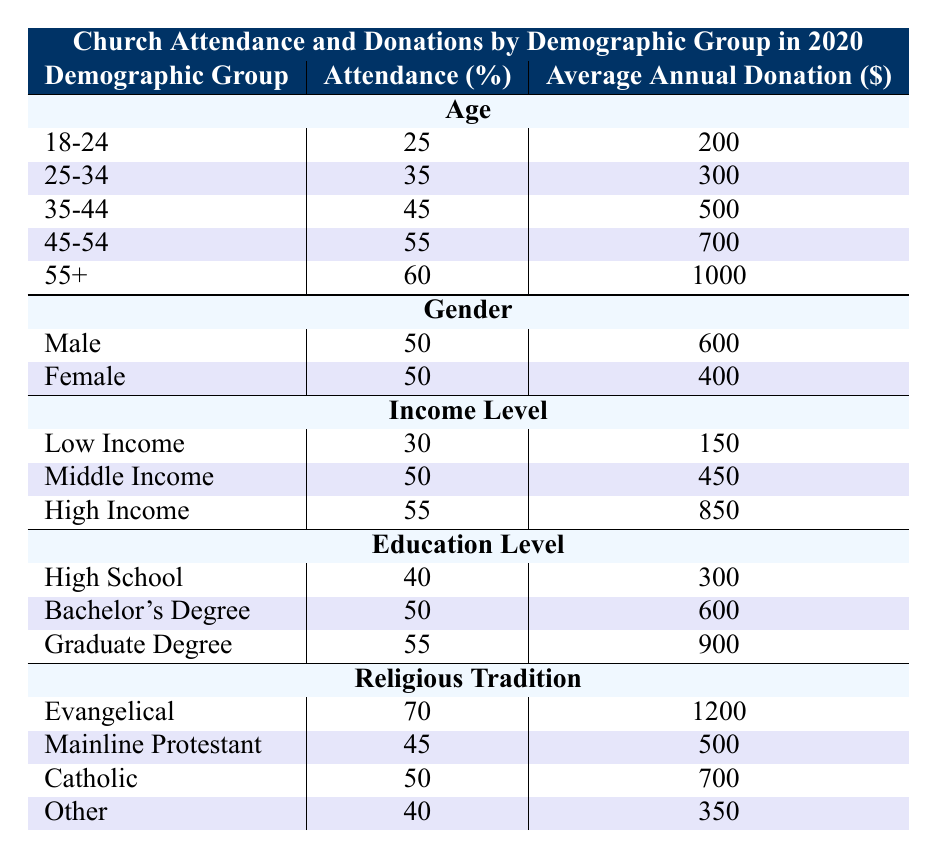What is the average church attendance percentage for the age group 35-44? The table shows that the church attendance percentage for the age group 35-44 is 45%.
Answer: 45% What is the average annual donation for individuals with a Graduate Degree? According to the table, those with a Graduate Degree have an average annual donation of $900.
Answer: $900 Which demographic group has the highest church attendance percentage? The Evangelical demographic group has the highest church attendance percentage at 70%.
Answer: 70% What is the difference in average annual donations between high-income and middle-income individuals? High-income individuals donate $850 on average, while middle-income individuals donate $450. The difference is $850 - $450 = $400.
Answer: $400 Is the average annual donation for females higher than for males? The average annual donation for females is $400, while males donate $600 on average. So no, it is not higher.
Answer: No What is the average attendance percentage for all age groups combined? To find the average attendance percentage for all age groups, we sum the attendance percentages: 25 + 35 + 45 + 55 + 60 = 220. Then divide by the number of groups (5), so 220 / 5 = 44%.
Answer: 44% Which income level contributes the lowest average annual donation? The table states that individuals in the Low Income category contribute the lowest average donation of $150.
Answer: $150 What percentage of the Evangelical demographic attends church compared to the Other demographic? Evangelicals have an attendance percentage of 70%, while the Other demographic has an attendance percentage of 40%. The difference is 70% - 40% = 30%.
Answer: 30% What is the combined average annual donation for those in the 45-54 and 55+ age groups? The average donations for the 45-54 and 55+ age groups are $700 and $1000, respectively. Their combined total is $700 + $1000 = $1700. To find the average, we divide by 2: $1700 / 2 = $850.
Answer: $850 Is church attendance higher among those with a Bachelor's Degree compared to those with a High School education? The attendance for those with a Bachelor's Degree is 50%, while it is 40% for those with a High School education. Since 50% is greater than 40%, the answer is yes.
Answer: Yes 